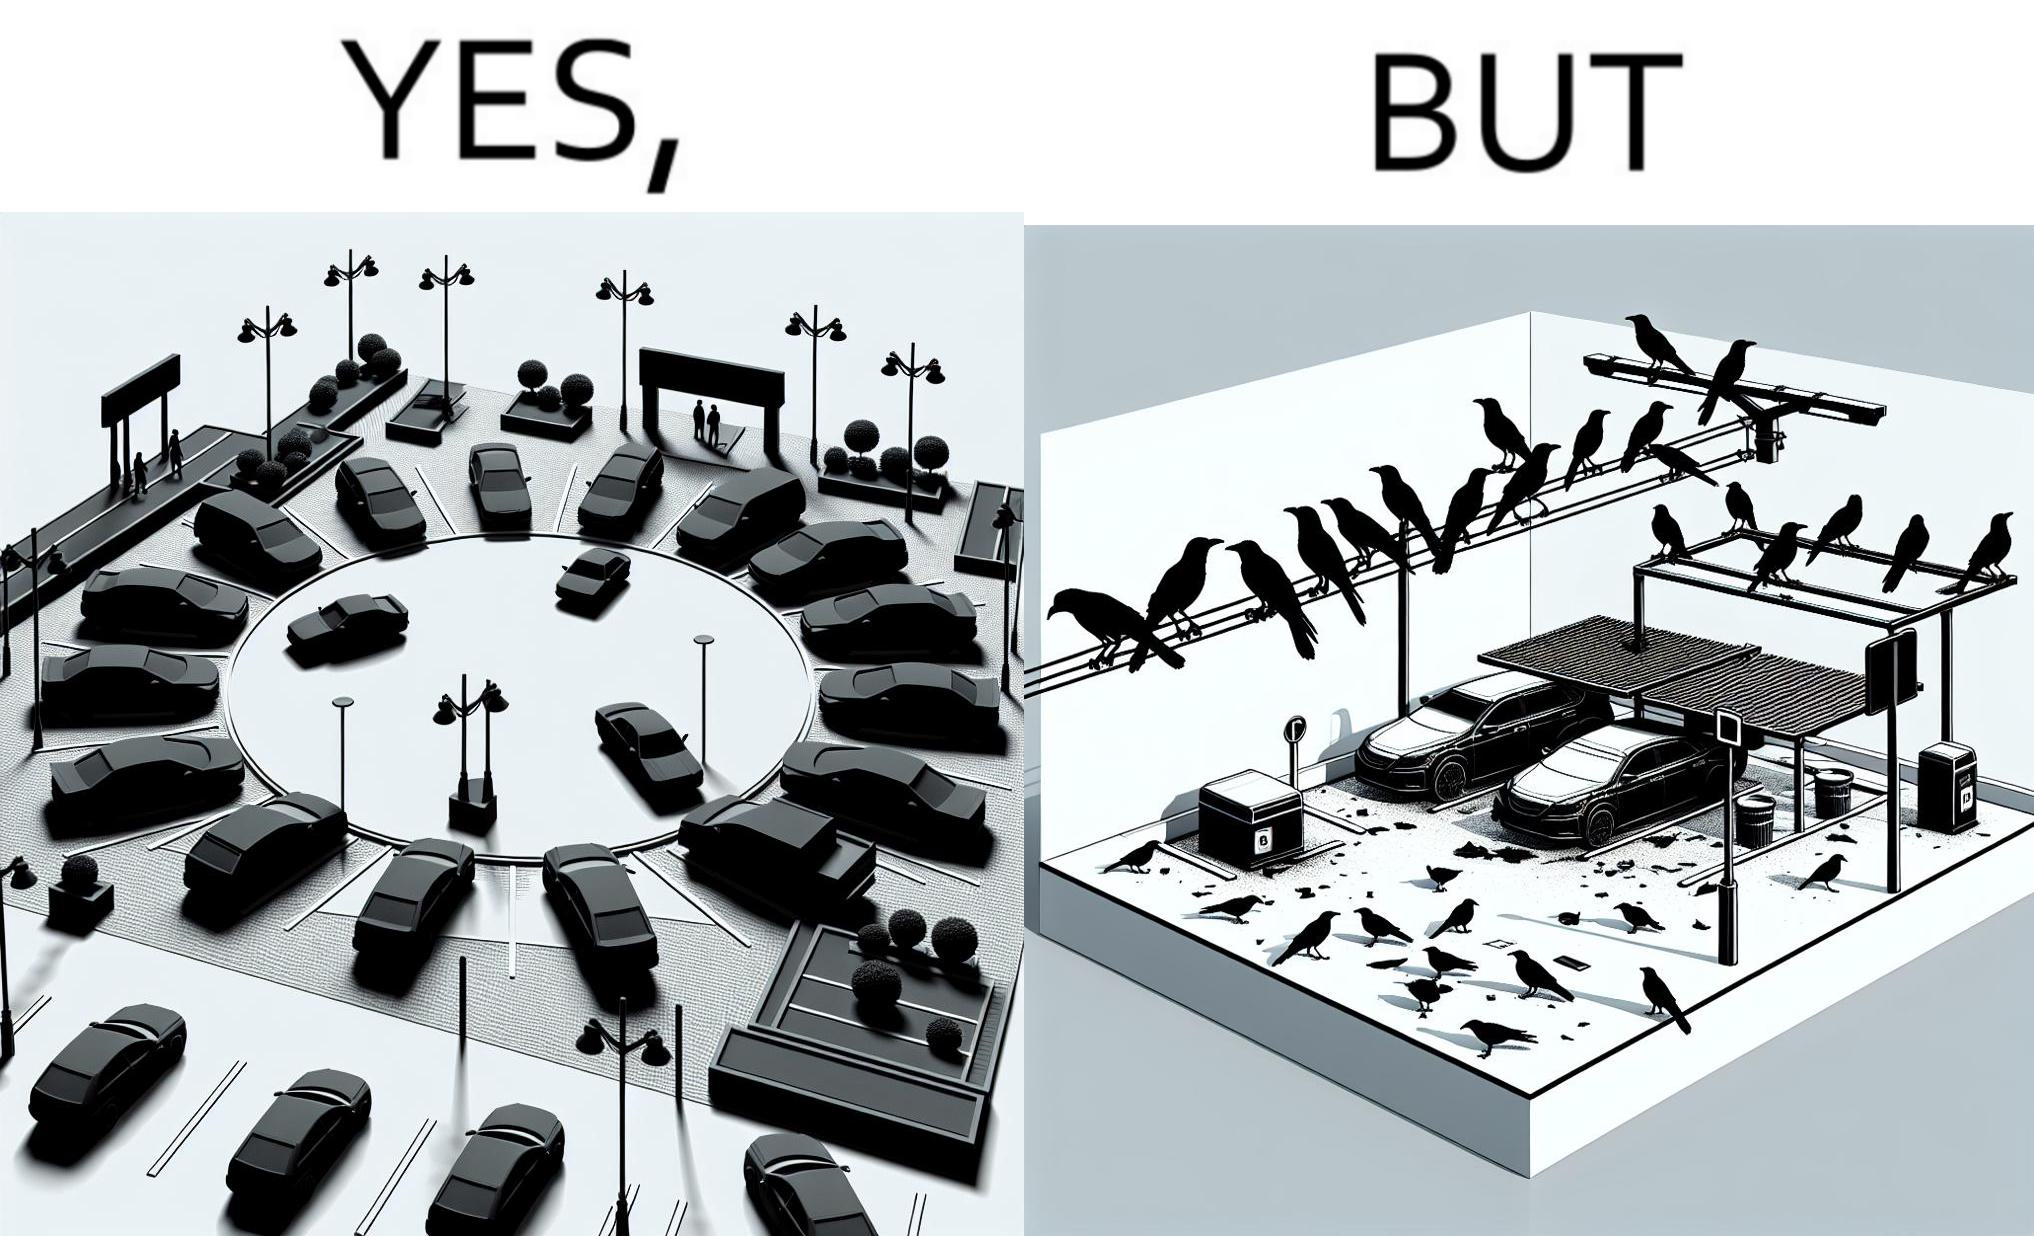Describe the content of this image. The image is ironical such that although there is a place for parking but that place is not suitable because if we place our car there then our car will become dirty from top due to crow beet. 